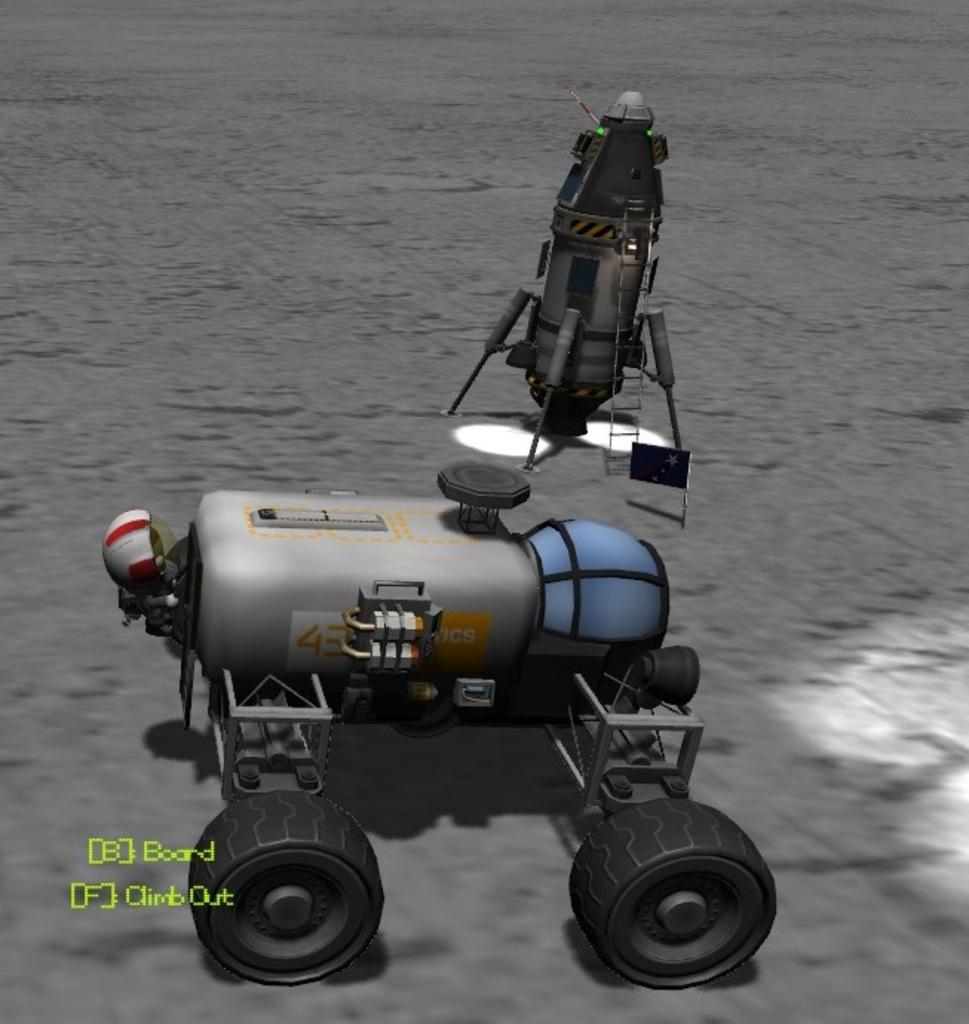What does the b button do?
Offer a very short reply. Board. 